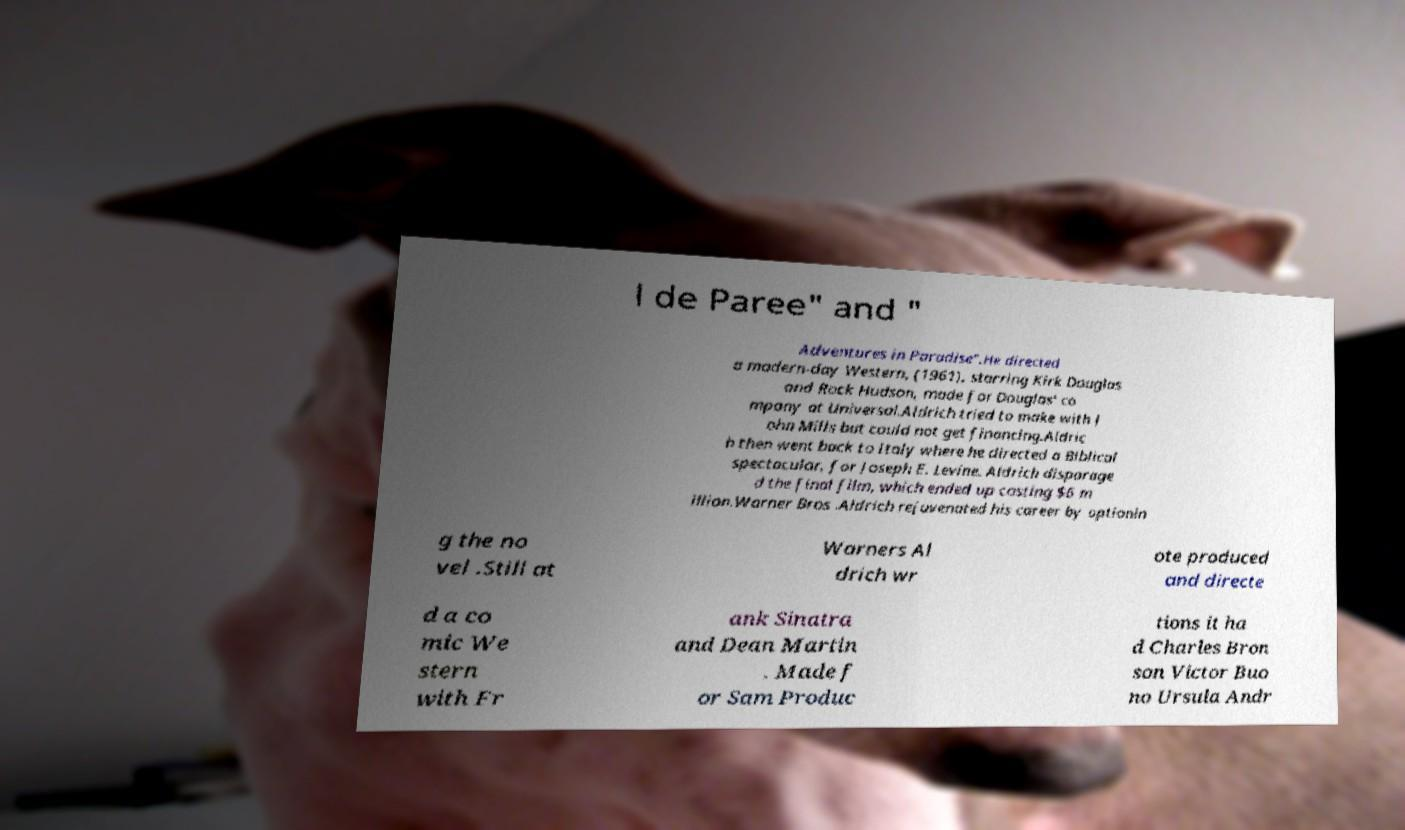Please identify and transcribe the text found in this image. l de Paree" and " Adventures in Paradise".He directed a modern-day Western, (1961), starring Kirk Douglas and Rock Hudson, made for Douglas' co mpany at Universal.Aldrich tried to make with J ohn Mills but could not get financing.Aldric h then went back to Italy where he directed a Biblical spectacular, for Joseph E. Levine. Aldrich disparage d the final film, which ended up costing $6 m illion.Warner Bros .Aldrich rejuvenated his career by optionin g the no vel .Still at Warners Al drich wr ote produced and directe d a co mic We stern with Fr ank Sinatra and Dean Martin . Made f or Sam Produc tions it ha d Charles Bron son Victor Buo no Ursula Andr 